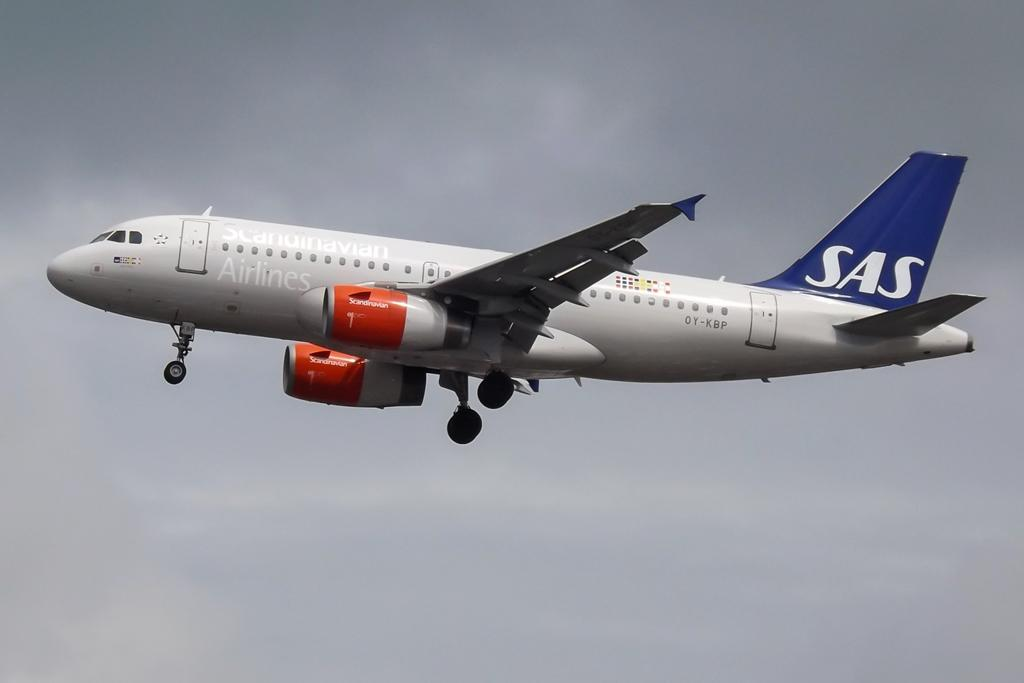<image>
Offer a succinct explanation of the picture presented. Scandinavian Airlines with a white SAS on the wing on a airplane. 